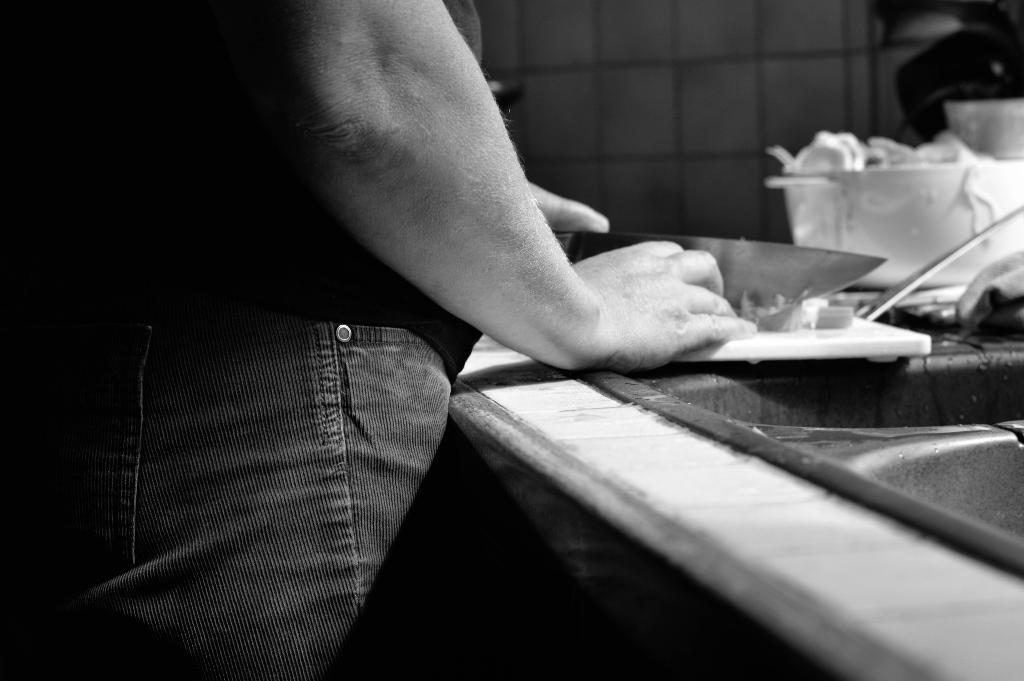What is the color scheme of the image? The image is black and white. Can you describe the main subject in the image? There is a person standing in the image. What object can be seen in the bottom right corner of the image? There is a wash basin in the bottom right corner of the image. What other objects are present in the image besides the person and wash basin? There are other objects present in the image, but their specific details are not mentioned in the provided facts. How many eggs are being raked by the person on the bridge in the image? There is no person, bridge, or eggs present in the image. The image is black and white and features a person standing and a wash basin in the bottom right corner. 